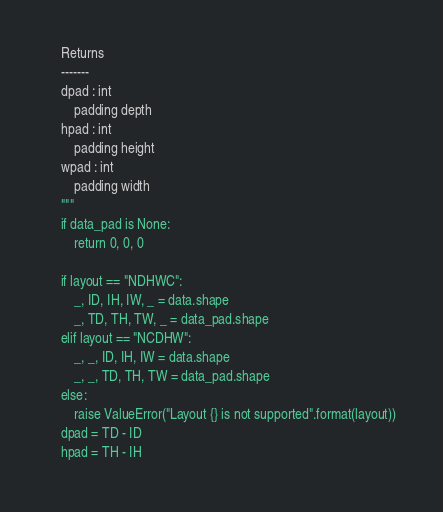Convert code to text. <code><loc_0><loc_0><loc_500><loc_500><_Python_>
    Returns
    -------
    dpad : int
        padding depth
    hpad : int
        padding height
    wpad : int
        padding width
    """
    if data_pad is None:
        return 0, 0, 0

    if layout == "NDHWC":
        _, ID, IH, IW, _ = data.shape
        _, TD, TH, TW, _ = data_pad.shape
    elif layout == "NCDHW":
        _, _, ID, IH, IW = data.shape
        _, _, TD, TH, TW = data_pad.shape
    else:
        raise ValueError("Layout {} is not supported".format(layout))
    dpad = TD - ID
    hpad = TH - IH</code> 